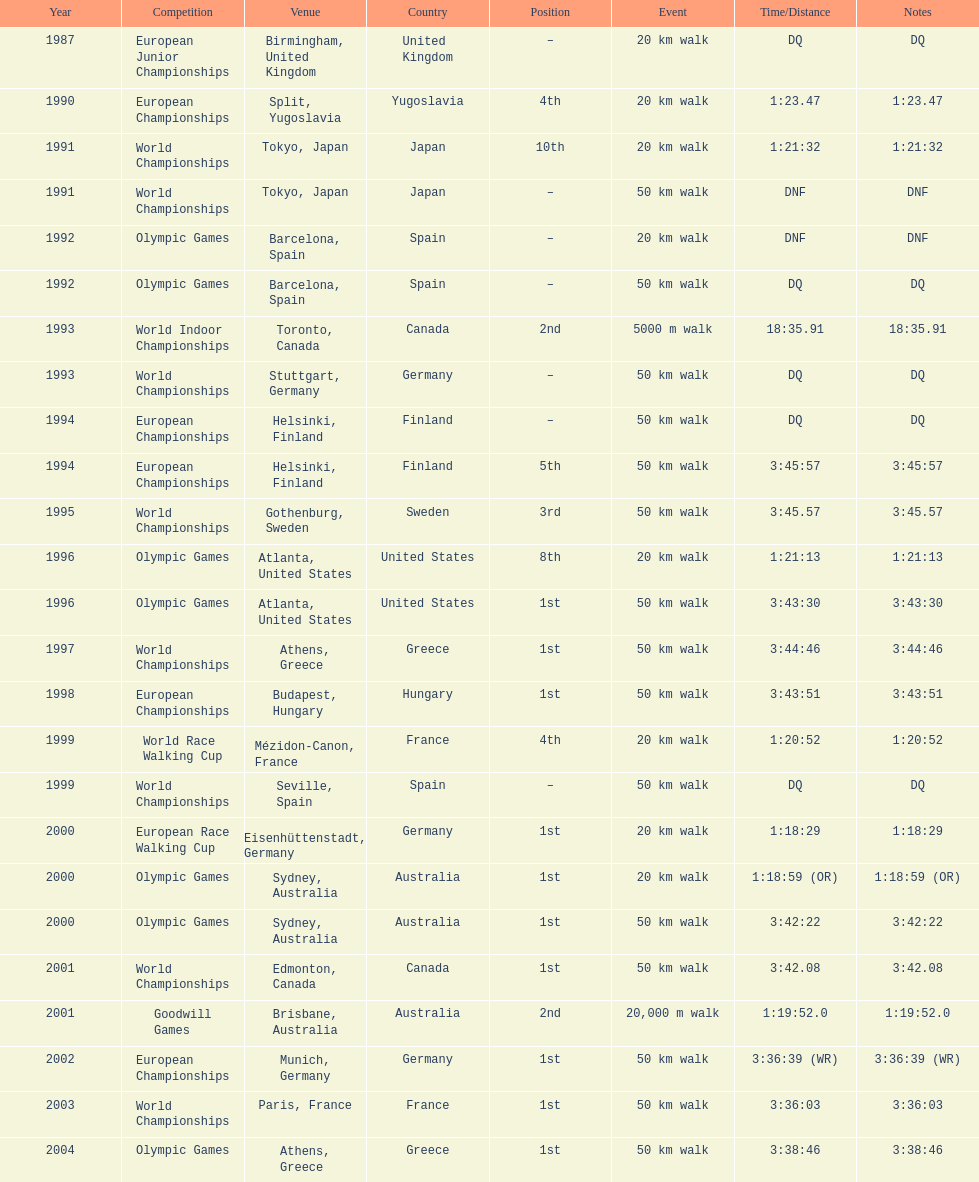What was the name of the competition that took place before the olympic games in 1996? World Championships. 